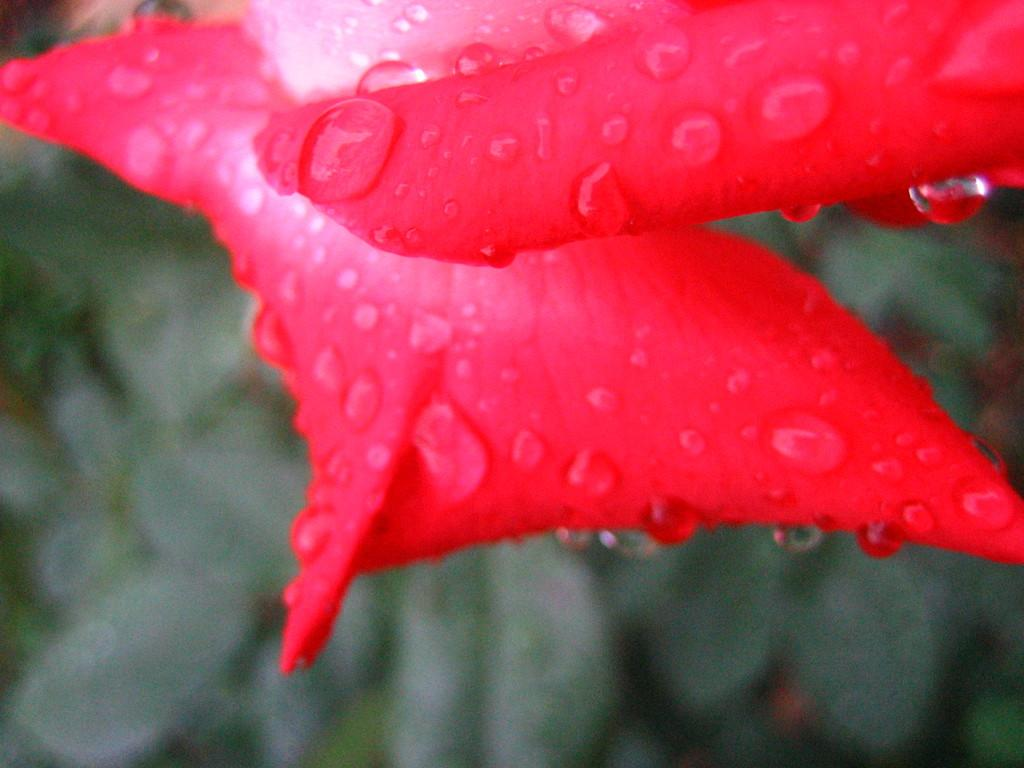What type of petals can be seen in the image? There are rose petals in the image. What color are the rose petals? The rose petals are red in color. Are there any additional features on the rose petals? Yes, there are water droplets on the rose petals. What can be seen in the background of the image? There are plants visible in the background of the image. What type of animal can be seen interacting with the rose petals in the image? There is no animal present in the image; it only features rose petals with water droplets and plants in the background. 